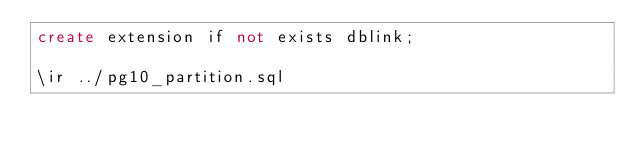<code> <loc_0><loc_0><loc_500><loc_500><_SQL_>create extension if not exists dblink;

\ir ../pg10_partition.sql
</code> 